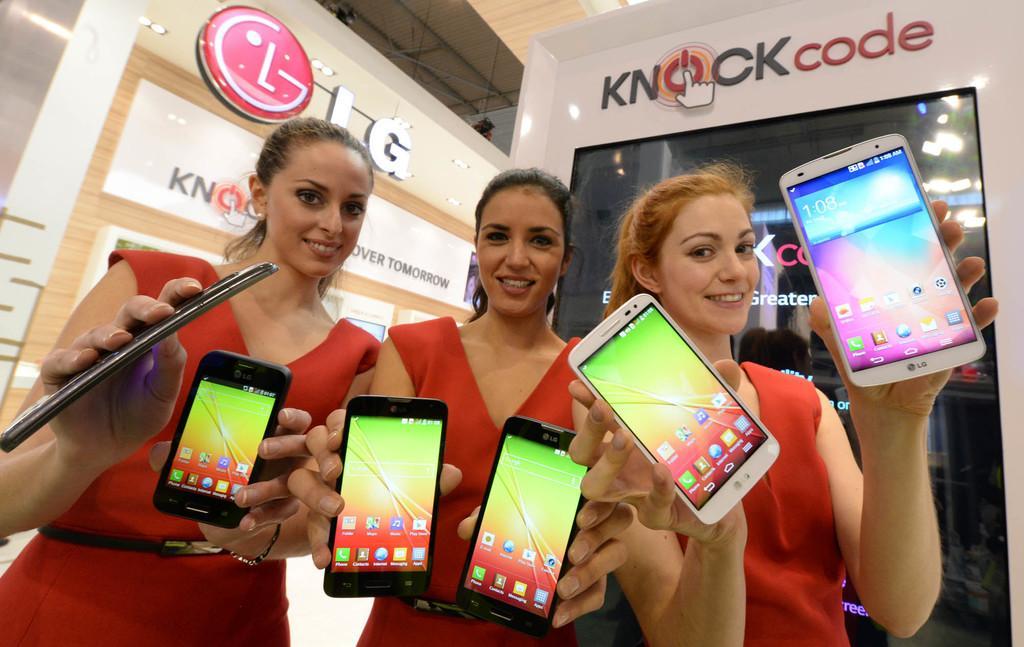In one or two sentences, can you explain what this image depicts? In this image there are three ladies wearing red dress and holding mobiles in their hands, in the background there are board, on that boards there is some text. 